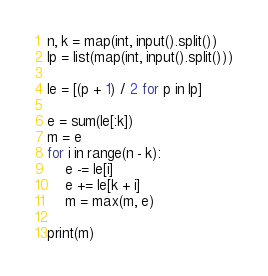<code> <loc_0><loc_0><loc_500><loc_500><_Python_>n, k = map(int, input().split())
lp = list(map(int, input().split()))

le = [(p + 1) / 2 for p in lp]

e = sum(le[:k])
m = e
for i in range(n - k):
    e -= le[i]
    e += le[k + i]
    m = max(m, e)

print(m)
</code> 